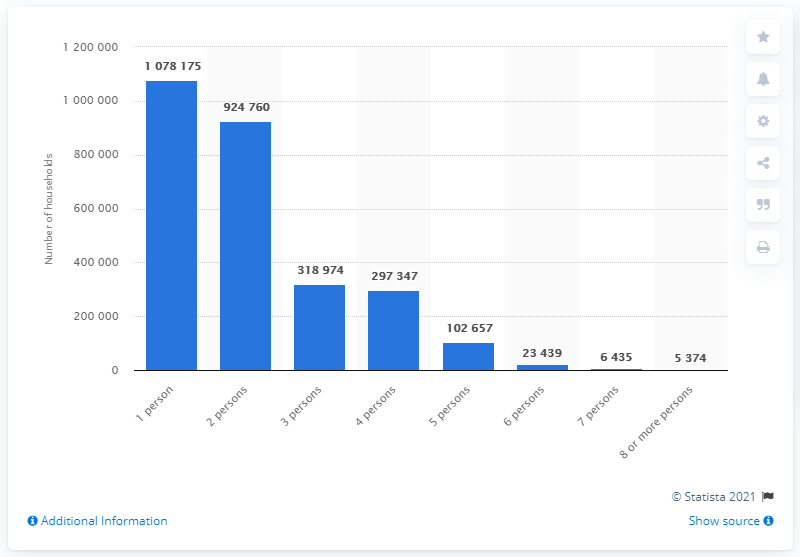Point out several critical features in this image. In 2021, there were approximately 924,760 households in Denmark. In 2021, there were 5,374 households in Denmark with eight or more inhabitants. 